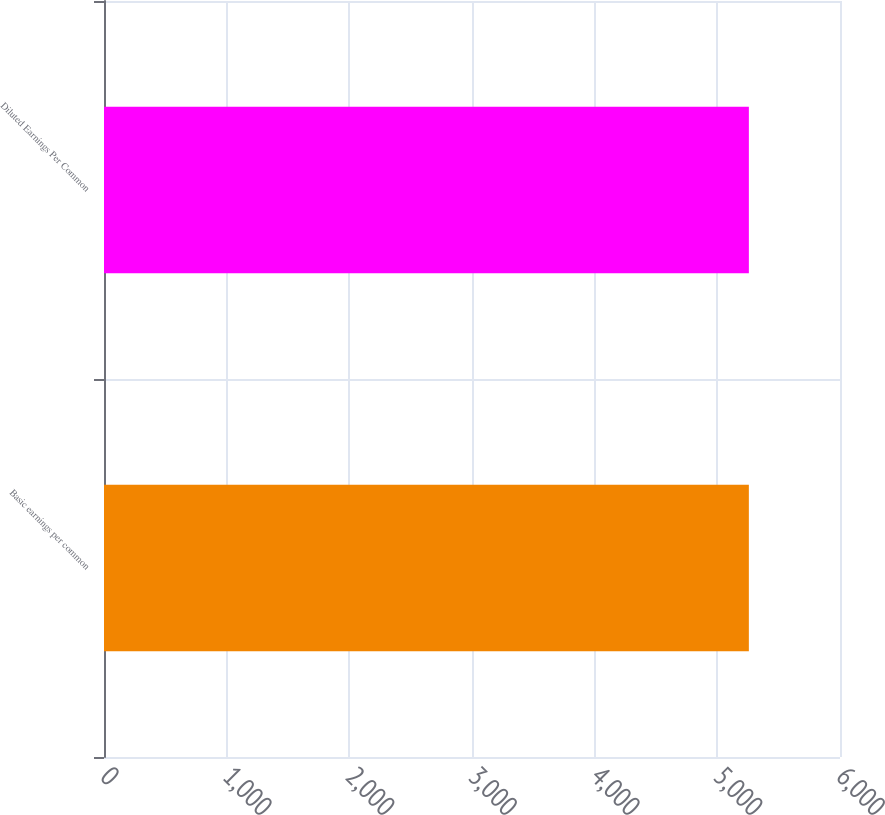Convert chart to OTSL. <chart><loc_0><loc_0><loc_500><loc_500><bar_chart><fcel>Basic earnings per common<fcel>Diluted Earnings Per Common<nl><fcel>5257<fcel>5257.1<nl></chart> 